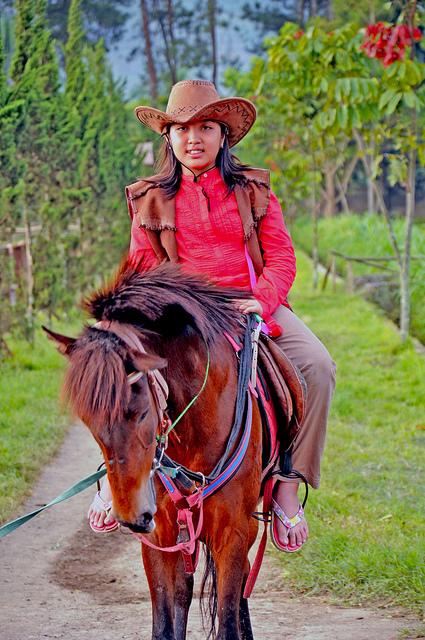Is she ready for the rodeo?
Answer briefly. Yes. Are her shoes typical of what a cowgirl would wear?
Concise answer only. No. What type of hat is this person wearing?
Keep it brief. Cowboy. What is the person's likely ethnicity?
Write a very short answer. Indian. 